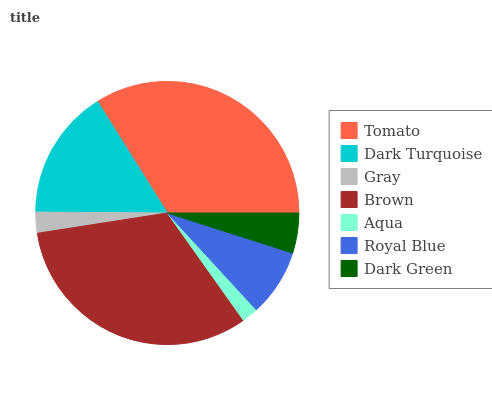Is Aqua the minimum?
Answer yes or no. Yes. Is Tomato the maximum?
Answer yes or no. Yes. Is Dark Turquoise the minimum?
Answer yes or no. No. Is Dark Turquoise the maximum?
Answer yes or no. No. Is Tomato greater than Dark Turquoise?
Answer yes or no. Yes. Is Dark Turquoise less than Tomato?
Answer yes or no. Yes. Is Dark Turquoise greater than Tomato?
Answer yes or no. No. Is Tomato less than Dark Turquoise?
Answer yes or no. No. Is Royal Blue the high median?
Answer yes or no. Yes. Is Royal Blue the low median?
Answer yes or no. Yes. Is Brown the high median?
Answer yes or no. No. Is Dark Green the low median?
Answer yes or no. No. 